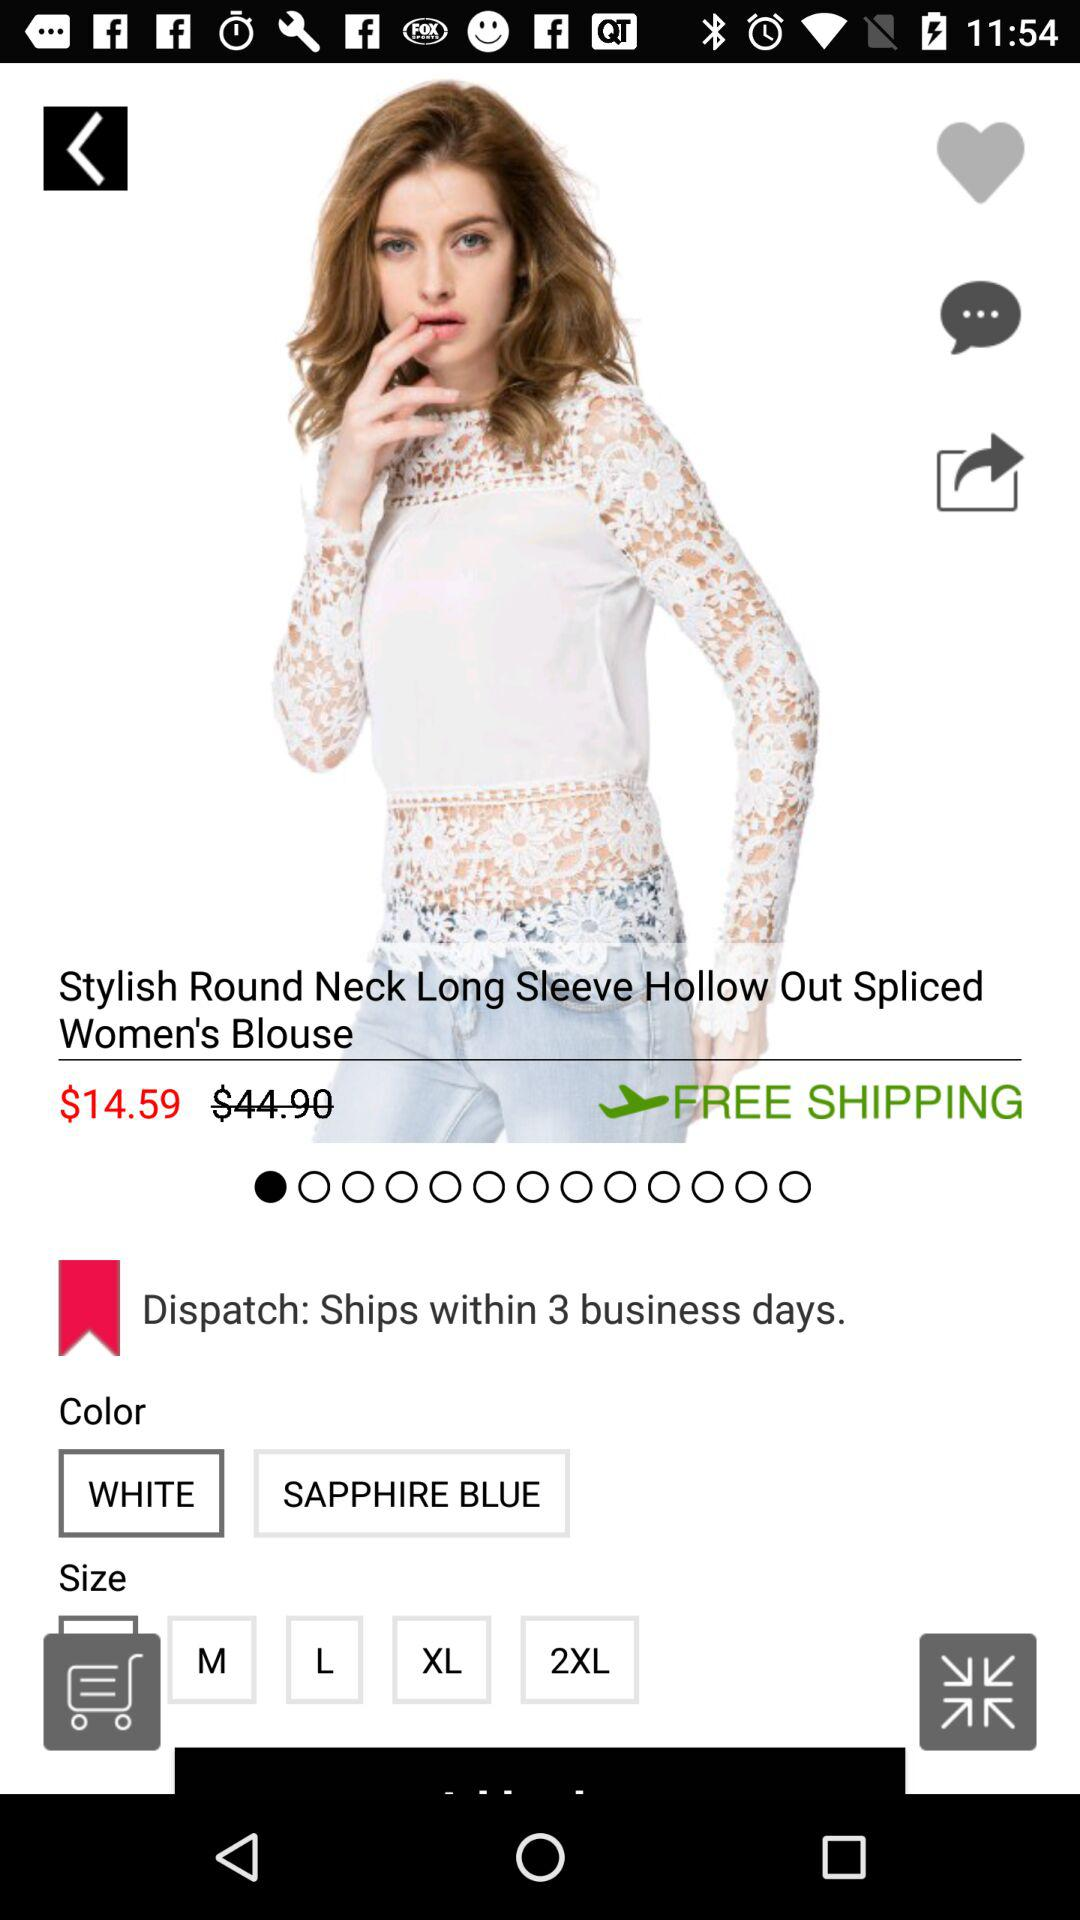What is the discounted price of the product? The discounted price of the product is $14.59. 